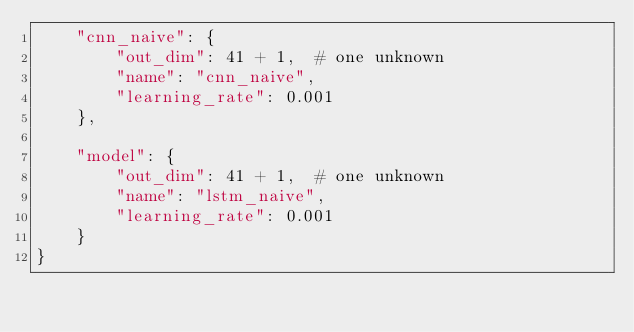Convert code to text. <code><loc_0><loc_0><loc_500><loc_500><_Python_>    "cnn_naive": {
        "out_dim": 41 + 1,  # one unknown
        "name": "cnn_naive",
        "learning_rate": 0.001
    },

    "model": {
        "out_dim": 41 + 1,  # one unknown
        "name": "lstm_naive",
        "learning_rate": 0.001
    }
}
</code> 